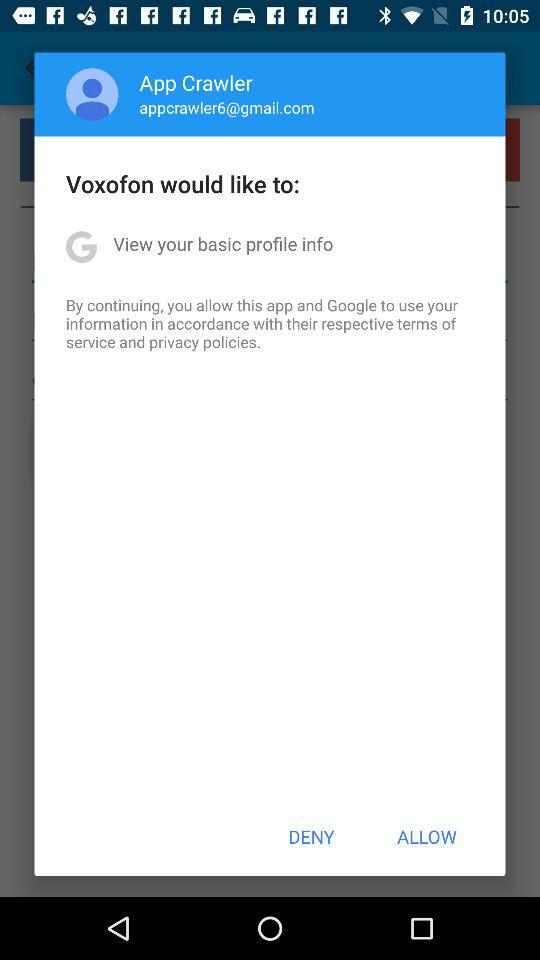What is the email ID of the user? The selected email ID is appcrawler6@gmail.com. 